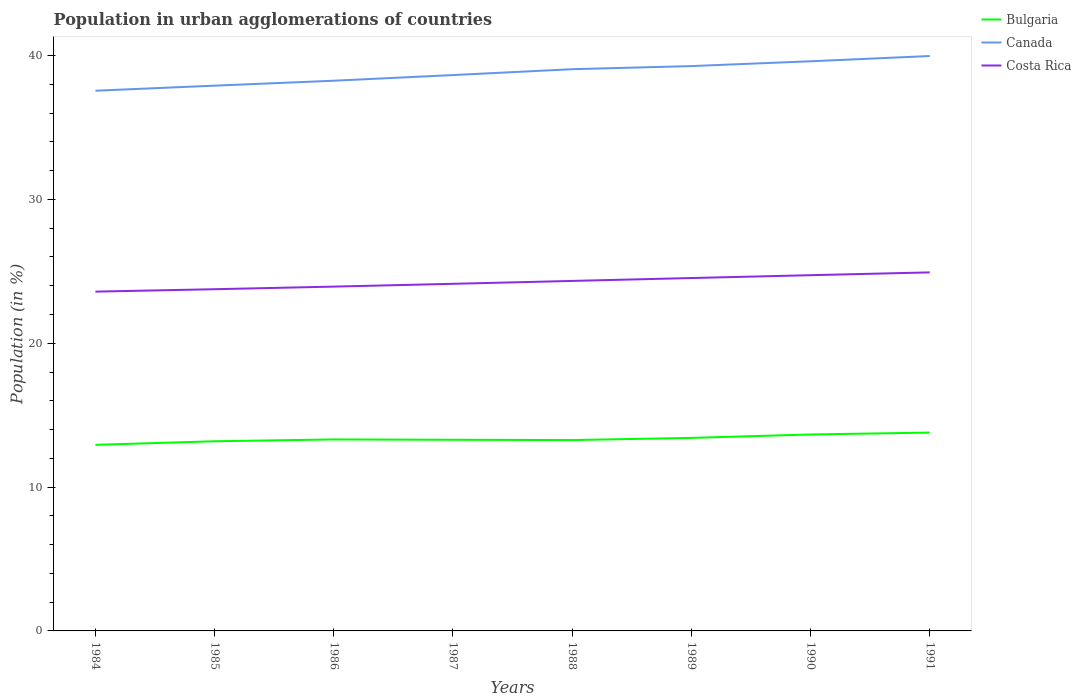Is the number of lines equal to the number of legend labels?
Provide a short and direct response. Yes. Across all years, what is the maximum percentage of population in urban agglomerations in Bulgaria?
Your response must be concise. 12.94. What is the total percentage of population in urban agglomerations in Canada in the graph?
Provide a succinct answer. -1.5. What is the difference between the highest and the second highest percentage of population in urban agglomerations in Bulgaria?
Give a very brief answer. 0.85. Is the percentage of population in urban agglomerations in Bulgaria strictly greater than the percentage of population in urban agglomerations in Costa Rica over the years?
Provide a short and direct response. Yes. What is the difference between two consecutive major ticks on the Y-axis?
Your response must be concise. 10. Does the graph contain any zero values?
Provide a short and direct response. No. Does the graph contain grids?
Your answer should be very brief. No. What is the title of the graph?
Offer a very short reply. Population in urban agglomerations of countries. Does "Comoros" appear as one of the legend labels in the graph?
Your answer should be very brief. No. What is the Population (in %) in Bulgaria in 1984?
Your answer should be compact. 12.94. What is the Population (in %) of Canada in 1984?
Ensure brevity in your answer.  37.56. What is the Population (in %) of Costa Rica in 1984?
Ensure brevity in your answer.  23.59. What is the Population (in %) of Bulgaria in 1985?
Your response must be concise. 13.19. What is the Population (in %) of Canada in 1985?
Provide a succinct answer. 37.91. What is the Population (in %) of Costa Rica in 1985?
Give a very brief answer. 23.76. What is the Population (in %) in Bulgaria in 1986?
Your answer should be very brief. 13.31. What is the Population (in %) in Canada in 1986?
Ensure brevity in your answer.  38.25. What is the Population (in %) in Costa Rica in 1986?
Give a very brief answer. 23.94. What is the Population (in %) of Bulgaria in 1987?
Keep it short and to the point. 13.29. What is the Population (in %) in Canada in 1987?
Keep it short and to the point. 38.64. What is the Population (in %) of Costa Rica in 1987?
Your response must be concise. 24.13. What is the Population (in %) in Bulgaria in 1988?
Give a very brief answer. 13.27. What is the Population (in %) in Canada in 1988?
Ensure brevity in your answer.  39.05. What is the Population (in %) in Costa Rica in 1988?
Give a very brief answer. 24.33. What is the Population (in %) in Bulgaria in 1989?
Keep it short and to the point. 13.42. What is the Population (in %) of Canada in 1989?
Your answer should be compact. 39.27. What is the Population (in %) in Costa Rica in 1989?
Offer a very short reply. 24.53. What is the Population (in %) in Bulgaria in 1990?
Offer a terse response. 13.66. What is the Population (in %) in Canada in 1990?
Keep it short and to the point. 39.6. What is the Population (in %) of Costa Rica in 1990?
Give a very brief answer. 24.73. What is the Population (in %) in Bulgaria in 1991?
Offer a very short reply. 13.79. What is the Population (in %) in Canada in 1991?
Offer a terse response. 39.97. What is the Population (in %) in Costa Rica in 1991?
Make the answer very short. 24.93. Across all years, what is the maximum Population (in %) in Bulgaria?
Ensure brevity in your answer.  13.79. Across all years, what is the maximum Population (in %) in Canada?
Ensure brevity in your answer.  39.97. Across all years, what is the maximum Population (in %) in Costa Rica?
Provide a succinct answer. 24.93. Across all years, what is the minimum Population (in %) in Bulgaria?
Provide a succinct answer. 12.94. Across all years, what is the minimum Population (in %) in Canada?
Your answer should be very brief. 37.56. Across all years, what is the minimum Population (in %) in Costa Rica?
Provide a short and direct response. 23.59. What is the total Population (in %) of Bulgaria in the graph?
Your response must be concise. 106.86. What is the total Population (in %) in Canada in the graph?
Your answer should be very brief. 310.25. What is the total Population (in %) of Costa Rica in the graph?
Give a very brief answer. 193.94. What is the difference between the Population (in %) of Bulgaria in 1984 and that in 1985?
Your answer should be compact. -0.25. What is the difference between the Population (in %) of Canada in 1984 and that in 1985?
Make the answer very short. -0.35. What is the difference between the Population (in %) of Costa Rica in 1984 and that in 1985?
Give a very brief answer. -0.17. What is the difference between the Population (in %) of Bulgaria in 1984 and that in 1986?
Provide a short and direct response. -0.38. What is the difference between the Population (in %) of Canada in 1984 and that in 1986?
Provide a short and direct response. -0.69. What is the difference between the Population (in %) of Costa Rica in 1984 and that in 1986?
Your response must be concise. -0.35. What is the difference between the Population (in %) of Bulgaria in 1984 and that in 1987?
Ensure brevity in your answer.  -0.35. What is the difference between the Population (in %) in Canada in 1984 and that in 1987?
Offer a terse response. -1.09. What is the difference between the Population (in %) in Costa Rica in 1984 and that in 1987?
Provide a short and direct response. -0.54. What is the difference between the Population (in %) in Bulgaria in 1984 and that in 1988?
Provide a short and direct response. -0.33. What is the difference between the Population (in %) in Canada in 1984 and that in 1988?
Keep it short and to the point. -1.5. What is the difference between the Population (in %) in Costa Rica in 1984 and that in 1988?
Your answer should be very brief. -0.74. What is the difference between the Population (in %) of Bulgaria in 1984 and that in 1989?
Provide a succinct answer. -0.48. What is the difference between the Population (in %) in Canada in 1984 and that in 1989?
Keep it short and to the point. -1.71. What is the difference between the Population (in %) of Costa Rica in 1984 and that in 1989?
Your response must be concise. -0.95. What is the difference between the Population (in %) of Bulgaria in 1984 and that in 1990?
Offer a very short reply. -0.72. What is the difference between the Population (in %) in Canada in 1984 and that in 1990?
Your answer should be very brief. -2.05. What is the difference between the Population (in %) in Costa Rica in 1984 and that in 1990?
Your answer should be very brief. -1.14. What is the difference between the Population (in %) in Bulgaria in 1984 and that in 1991?
Your response must be concise. -0.85. What is the difference between the Population (in %) in Canada in 1984 and that in 1991?
Provide a succinct answer. -2.41. What is the difference between the Population (in %) in Costa Rica in 1984 and that in 1991?
Ensure brevity in your answer.  -1.34. What is the difference between the Population (in %) of Bulgaria in 1985 and that in 1986?
Provide a short and direct response. -0.13. What is the difference between the Population (in %) in Canada in 1985 and that in 1986?
Your response must be concise. -0.34. What is the difference between the Population (in %) in Costa Rica in 1985 and that in 1986?
Your answer should be very brief. -0.18. What is the difference between the Population (in %) of Bulgaria in 1985 and that in 1987?
Give a very brief answer. -0.1. What is the difference between the Population (in %) in Canada in 1985 and that in 1987?
Your answer should be compact. -0.74. What is the difference between the Population (in %) in Costa Rica in 1985 and that in 1987?
Your answer should be compact. -0.38. What is the difference between the Population (in %) of Bulgaria in 1985 and that in 1988?
Offer a very short reply. -0.08. What is the difference between the Population (in %) in Canada in 1985 and that in 1988?
Make the answer very short. -1.14. What is the difference between the Population (in %) in Costa Rica in 1985 and that in 1988?
Give a very brief answer. -0.58. What is the difference between the Population (in %) of Bulgaria in 1985 and that in 1989?
Your answer should be very brief. -0.23. What is the difference between the Population (in %) in Canada in 1985 and that in 1989?
Ensure brevity in your answer.  -1.36. What is the difference between the Population (in %) of Costa Rica in 1985 and that in 1989?
Your answer should be very brief. -0.78. What is the difference between the Population (in %) in Bulgaria in 1985 and that in 1990?
Your response must be concise. -0.47. What is the difference between the Population (in %) in Canada in 1985 and that in 1990?
Ensure brevity in your answer.  -1.7. What is the difference between the Population (in %) of Costa Rica in 1985 and that in 1990?
Give a very brief answer. -0.98. What is the difference between the Population (in %) of Bulgaria in 1985 and that in 1991?
Your answer should be compact. -0.6. What is the difference between the Population (in %) of Canada in 1985 and that in 1991?
Your answer should be very brief. -2.06. What is the difference between the Population (in %) in Costa Rica in 1985 and that in 1991?
Ensure brevity in your answer.  -1.17. What is the difference between the Population (in %) in Bulgaria in 1986 and that in 1987?
Provide a short and direct response. 0.02. What is the difference between the Population (in %) in Canada in 1986 and that in 1987?
Provide a succinct answer. -0.39. What is the difference between the Population (in %) in Costa Rica in 1986 and that in 1987?
Make the answer very short. -0.2. What is the difference between the Population (in %) in Bulgaria in 1986 and that in 1988?
Provide a succinct answer. 0.04. What is the difference between the Population (in %) of Canada in 1986 and that in 1988?
Provide a succinct answer. -0.8. What is the difference between the Population (in %) in Costa Rica in 1986 and that in 1988?
Offer a terse response. -0.4. What is the difference between the Population (in %) in Bulgaria in 1986 and that in 1989?
Your response must be concise. -0.11. What is the difference between the Population (in %) in Canada in 1986 and that in 1989?
Make the answer very short. -1.02. What is the difference between the Population (in %) in Costa Rica in 1986 and that in 1989?
Your response must be concise. -0.6. What is the difference between the Population (in %) in Bulgaria in 1986 and that in 1990?
Offer a terse response. -0.35. What is the difference between the Population (in %) in Canada in 1986 and that in 1990?
Your answer should be very brief. -1.35. What is the difference between the Population (in %) of Costa Rica in 1986 and that in 1990?
Provide a succinct answer. -0.79. What is the difference between the Population (in %) of Bulgaria in 1986 and that in 1991?
Keep it short and to the point. -0.48. What is the difference between the Population (in %) in Canada in 1986 and that in 1991?
Make the answer very short. -1.72. What is the difference between the Population (in %) in Costa Rica in 1986 and that in 1991?
Provide a short and direct response. -0.99. What is the difference between the Population (in %) of Canada in 1987 and that in 1988?
Provide a short and direct response. -0.41. What is the difference between the Population (in %) in Costa Rica in 1987 and that in 1988?
Make the answer very short. -0.2. What is the difference between the Population (in %) of Bulgaria in 1987 and that in 1989?
Your response must be concise. -0.13. What is the difference between the Population (in %) of Canada in 1987 and that in 1989?
Offer a very short reply. -0.62. What is the difference between the Population (in %) in Costa Rica in 1987 and that in 1989?
Your response must be concise. -0.4. What is the difference between the Population (in %) of Bulgaria in 1987 and that in 1990?
Your answer should be compact. -0.37. What is the difference between the Population (in %) in Canada in 1987 and that in 1990?
Your response must be concise. -0.96. What is the difference between the Population (in %) in Costa Rica in 1987 and that in 1990?
Your answer should be very brief. -0.6. What is the difference between the Population (in %) in Bulgaria in 1987 and that in 1991?
Your response must be concise. -0.5. What is the difference between the Population (in %) of Canada in 1987 and that in 1991?
Give a very brief answer. -1.32. What is the difference between the Population (in %) of Costa Rica in 1987 and that in 1991?
Make the answer very short. -0.79. What is the difference between the Population (in %) in Bulgaria in 1988 and that in 1989?
Your answer should be compact. -0.15. What is the difference between the Population (in %) of Canada in 1988 and that in 1989?
Offer a very short reply. -0.22. What is the difference between the Population (in %) of Costa Rica in 1988 and that in 1989?
Ensure brevity in your answer.  -0.2. What is the difference between the Population (in %) of Bulgaria in 1988 and that in 1990?
Give a very brief answer. -0.39. What is the difference between the Population (in %) in Canada in 1988 and that in 1990?
Ensure brevity in your answer.  -0.55. What is the difference between the Population (in %) of Costa Rica in 1988 and that in 1990?
Ensure brevity in your answer.  -0.4. What is the difference between the Population (in %) in Bulgaria in 1988 and that in 1991?
Offer a terse response. -0.52. What is the difference between the Population (in %) in Canada in 1988 and that in 1991?
Provide a short and direct response. -0.92. What is the difference between the Population (in %) of Costa Rica in 1988 and that in 1991?
Keep it short and to the point. -0.59. What is the difference between the Population (in %) of Bulgaria in 1989 and that in 1990?
Make the answer very short. -0.24. What is the difference between the Population (in %) of Canada in 1989 and that in 1990?
Your answer should be very brief. -0.33. What is the difference between the Population (in %) of Costa Rica in 1989 and that in 1990?
Offer a terse response. -0.2. What is the difference between the Population (in %) of Bulgaria in 1989 and that in 1991?
Keep it short and to the point. -0.37. What is the difference between the Population (in %) in Canada in 1989 and that in 1991?
Offer a terse response. -0.7. What is the difference between the Population (in %) of Costa Rica in 1989 and that in 1991?
Keep it short and to the point. -0.39. What is the difference between the Population (in %) in Bulgaria in 1990 and that in 1991?
Your response must be concise. -0.13. What is the difference between the Population (in %) in Canada in 1990 and that in 1991?
Provide a short and direct response. -0.37. What is the difference between the Population (in %) of Costa Rica in 1990 and that in 1991?
Make the answer very short. -0.19. What is the difference between the Population (in %) in Bulgaria in 1984 and the Population (in %) in Canada in 1985?
Your answer should be very brief. -24.97. What is the difference between the Population (in %) of Bulgaria in 1984 and the Population (in %) of Costa Rica in 1985?
Offer a terse response. -10.82. What is the difference between the Population (in %) in Canada in 1984 and the Population (in %) in Costa Rica in 1985?
Offer a terse response. 13.8. What is the difference between the Population (in %) of Bulgaria in 1984 and the Population (in %) of Canada in 1986?
Your response must be concise. -25.31. What is the difference between the Population (in %) in Bulgaria in 1984 and the Population (in %) in Costa Rica in 1986?
Give a very brief answer. -11. What is the difference between the Population (in %) of Canada in 1984 and the Population (in %) of Costa Rica in 1986?
Make the answer very short. 13.62. What is the difference between the Population (in %) in Bulgaria in 1984 and the Population (in %) in Canada in 1987?
Offer a very short reply. -25.71. What is the difference between the Population (in %) in Bulgaria in 1984 and the Population (in %) in Costa Rica in 1987?
Make the answer very short. -11.19. What is the difference between the Population (in %) in Canada in 1984 and the Population (in %) in Costa Rica in 1987?
Your answer should be very brief. 13.42. What is the difference between the Population (in %) in Bulgaria in 1984 and the Population (in %) in Canada in 1988?
Ensure brevity in your answer.  -26.11. What is the difference between the Population (in %) in Bulgaria in 1984 and the Population (in %) in Costa Rica in 1988?
Keep it short and to the point. -11.4. What is the difference between the Population (in %) of Canada in 1984 and the Population (in %) of Costa Rica in 1988?
Keep it short and to the point. 13.22. What is the difference between the Population (in %) in Bulgaria in 1984 and the Population (in %) in Canada in 1989?
Your response must be concise. -26.33. What is the difference between the Population (in %) in Bulgaria in 1984 and the Population (in %) in Costa Rica in 1989?
Keep it short and to the point. -11.6. What is the difference between the Population (in %) in Canada in 1984 and the Population (in %) in Costa Rica in 1989?
Provide a succinct answer. 13.02. What is the difference between the Population (in %) in Bulgaria in 1984 and the Population (in %) in Canada in 1990?
Offer a very short reply. -26.67. What is the difference between the Population (in %) in Bulgaria in 1984 and the Population (in %) in Costa Rica in 1990?
Provide a short and direct response. -11.79. What is the difference between the Population (in %) of Canada in 1984 and the Population (in %) of Costa Rica in 1990?
Keep it short and to the point. 12.83. What is the difference between the Population (in %) in Bulgaria in 1984 and the Population (in %) in Canada in 1991?
Provide a short and direct response. -27.03. What is the difference between the Population (in %) of Bulgaria in 1984 and the Population (in %) of Costa Rica in 1991?
Provide a short and direct response. -11.99. What is the difference between the Population (in %) of Canada in 1984 and the Population (in %) of Costa Rica in 1991?
Ensure brevity in your answer.  12.63. What is the difference between the Population (in %) of Bulgaria in 1985 and the Population (in %) of Canada in 1986?
Your response must be concise. -25.07. What is the difference between the Population (in %) of Bulgaria in 1985 and the Population (in %) of Costa Rica in 1986?
Give a very brief answer. -10.75. What is the difference between the Population (in %) in Canada in 1985 and the Population (in %) in Costa Rica in 1986?
Give a very brief answer. 13.97. What is the difference between the Population (in %) in Bulgaria in 1985 and the Population (in %) in Canada in 1987?
Keep it short and to the point. -25.46. What is the difference between the Population (in %) of Bulgaria in 1985 and the Population (in %) of Costa Rica in 1987?
Provide a short and direct response. -10.95. What is the difference between the Population (in %) of Canada in 1985 and the Population (in %) of Costa Rica in 1987?
Your answer should be very brief. 13.78. What is the difference between the Population (in %) of Bulgaria in 1985 and the Population (in %) of Canada in 1988?
Give a very brief answer. -25.87. What is the difference between the Population (in %) in Bulgaria in 1985 and the Population (in %) in Costa Rica in 1988?
Offer a very short reply. -11.15. What is the difference between the Population (in %) of Canada in 1985 and the Population (in %) of Costa Rica in 1988?
Your response must be concise. 13.57. What is the difference between the Population (in %) in Bulgaria in 1985 and the Population (in %) in Canada in 1989?
Give a very brief answer. -26.08. What is the difference between the Population (in %) in Bulgaria in 1985 and the Population (in %) in Costa Rica in 1989?
Make the answer very short. -11.35. What is the difference between the Population (in %) in Canada in 1985 and the Population (in %) in Costa Rica in 1989?
Offer a terse response. 13.37. What is the difference between the Population (in %) in Bulgaria in 1985 and the Population (in %) in Canada in 1990?
Ensure brevity in your answer.  -26.42. What is the difference between the Population (in %) in Bulgaria in 1985 and the Population (in %) in Costa Rica in 1990?
Provide a short and direct response. -11.55. What is the difference between the Population (in %) of Canada in 1985 and the Population (in %) of Costa Rica in 1990?
Provide a short and direct response. 13.18. What is the difference between the Population (in %) of Bulgaria in 1985 and the Population (in %) of Canada in 1991?
Offer a terse response. -26.78. What is the difference between the Population (in %) of Bulgaria in 1985 and the Population (in %) of Costa Rica in 1991?
Your answer should be compact. -11.74. What is the difference between the Population (in %) in Canada in 1985 and the Population (in %) in Costa Rica in 1991?
Offer a very short reply. 12.98. What is the difference between the Population (in %) in Bulgaria in 1986 and the Population (in %) in Canada in 1987?
Ensure brevity in your answer.  -25.33. What is the difference between the Population (in %) in Bulgaria in 1986 and the Population (in %) in Costa Rica in 1987?
Your answer should be very brief. -10.82. What is the difference between the Population (in %) in Canada in 1986 and the Population (in %) in Costa Rica in 1987?
Provide a short and direct response. 14.12. What is the difference between the Population (in %) in Bulgaria in 1986 and the Population (in %) in Canada in 1988?
Provide a short and direct response. -25.74. What is the difference between the Population (in %) of Bulgaria in 1986 and the Population (in %) of Costa Rica in 1988?
Provide a succinct answer. -11.02. What is the difference between the Population (in %) of Canada in 1986 and the Population (in %) of Costa Rica in 1988?
Your response must be concise. 13.92. What is the difference between the Population (in %) in Bulgaria in 1986 and the Population (in %) in Canada in 1989?
Your answer should be very brief. -25.96. What is the difference between the Population (in %) of Bulgaria in 1986 and the Population (in %) of Costa Rica in 1989?
Make the answer very short. -11.22. What is the difference between the Population (in %) in Canada in 1986 and the Population (in %) in Costa Rica in 1989?
Offer a very short reply. 13.72. What is the difference between the Population (in %) of Bulgaria in 1986 and the Population (in %) of Canada in 1990?
Your answer should be very brief. -26.29. What is the difference between the Population (in %) in Bulgaria in 1986 and the Population (in %) in Costa Rica in 1990?
Make the answer very short. -11.42. What is the difference between the Population (in %) in Canada in 1986 and the Population (in %) in Costa Rica in 1990?
Offer a terse response. 13.52. What is the difference between the Population (in %) in Bulgaria in 1986 and the Population (in %) in Canada in 1991?
Provide a short and direct response. -26.66. What is the difference between the Population (in %) of Bulgaria in 1986 and the Population (in %) of Costa Rica in 1991?
Give a very brief answer. -11.61. What is the difference between the Population (in %) in Canada in 1986 and the Population (in %) in Costa Rica in 1991?
Make the answer very short. 13.33. What is the difference between the Population (in %) in Bulgaria in 1987 and the Population (in %) in Canada in 1988?
Keep it short and to the point. -25.76. What is the difference between the Population (in %) of Bulgaria in 1987 and the Population (in %) of Costa Rica in 1988?
Give a very brief answer. -11.04. What is the difference between the Population (in %) in Canada in 1987 and the Population (in %) in Costa Rica in 1988?
Offer a terse response. 14.31. What is the difference between the Population (in %) in Bulgaria in 1987 and the Population (in %) in Canada in 1989?
Your answer should be very brief. -25.98. What is the difference between the Population (in %) in Bulgaria in 1987 and the Population (in %) in Costa Rica in 1989?
Offer a very short reply. -11.25. What is the difference between the Population (in %) of Canada in 1987 and the Population (in %) of Costa Rica in 1989?
Keep it short and to the point. 14.11. What is the difference between the Population (in %) of Bulgaria in 1987 and the Population (in %) of Canada in 1990?
Your answer should be very brief. -26.31. What is the difference between the Population (in %) in Bulgaria in 1987 and the Population (in %) in Costa Rica in 1990?
Ensure brevity in your answer.  -11.44. What is the difference between the Population (in %) in Canada in 1987 and the Population (in %) in Costa Rica in 1990?
Offer a terse response. 13.91. What is the difference between the Population (in %) of Bulgaria in 1987 and the Population (in %) of Canada in 1991?
Your answer should be very brief. -26.68. What is the difference between the Population (in %) in Bulgaria in 1987 and the Population (in %) in Costa Rica in 1991?
Your answer should be very brief. -11.64. What is the difference between the Population (in %) in Canada in 1987 and the Population (in %) in Costa Rica in 1991?
Offer a terse response. 13.72. What is the difference between the Population (in %) of Bulgaria in 1988 and the Population (in %) of Canada in 1989?
Offer a very short reply. -26. What is the difference between the Population (in %) of Bulgaria in 1988 and the Population (in %) of Costa Rica in 1989?
Provide a short and direct response. -11.27. What is the difference between the Population (in %) in Canada in 1988 and the Population (in %) in Costa Rica in 1989?
Your answer should be very brief. 14.52. What is the difference between the Population (in %) in Bulgaria in 1988 and the Population (in %) in Canada in 1990?
Your answer should be very brief. -26.33. What is the difference between the Population (in %) in Bulgaria in 1988 and the Population (in %) in Costa Rica in 1990?
Make the answer very short. -11.46. What is the difference between the Population (in %) of Canada in 1988 and the Population (in %) of Costa Rica in 1990?
Your answer should be compact. 14.32. What is the difference between the Population (in %) in Bulgaria in 1988 and the Population (in %) in Canada in 1991?
Make the answer very short. -26.7. What is the difference between the Population (in %) of Bulgaria in 1988 and the Population (in %) of Costa Rica in 1991?
Offer a very short reply. -11.66. What is the difference between the Population (in %) in Canada in 1988 and the Population (in %) in Costa Rica in 1991?
Ensure brevity in your answer.  14.13. What is the difference between the Population (in %) of Bulgaria in 1989 and the Population (in %) of Canada in 1990?
Make the answer very short. -26.18. What is the difference between the Population (in %) of Bulgaria in 1989 and the Population (in %) of Costa Rica in 1990?
Your answer should be very brief. -11.31. What is the difference between the Population (in %) in Canada in 1989 and the Population (in %) in Costa Rica in 1990?
Provide a short and direct response. 14.54. What is the difference between the Population (in %) in Bulgaria in 1989 and the Population (in %) in Canada in 1991?
Give a very brief answer. -26.55. What is the difference between the Population (in %) of Bulgaria in 1989 and the Population (in %) of Costa Rica in 1991?
Ensure brevity in your answer.  -11.51. What is the difference between the Population (in %) of Canada in 1989 and the Population (in %) of Costa Rica in 1991?
Ensure brevity in your answer.  14.34. What is the difference between the Population (in %) in Bulgaria in 1990 and the Population (in %) in Canada in 1991?
Provide a succinct answer. -26.31. What is the difference between the Population (in %) of Bulgaria in 1990 and the Population (in %) of Costa Rica in 1991?
Keep it short and to the point. -11.27. What is the difference between the Population (in %) in Canada in 1990 and the Population (in %) in Costa Rica in 1991?
Your answer should be very brief. 14.68. What is the average Population (in %) of Bulgaria per year?
Ensure brevity in your answer.  13.36. What is the average Population (in %) in Canada per year?
Provide a succinct answer. 38.78. What is the average Population (in %) in Costa Rica per year?
Provide a short and direct response. 24.24. In the year 1984, what is the difference between the Population (in %) in Bulgaria and Population (in %) in Canada?
Ensure brevity in your answer.  -24.62. In the year 1984, what is the difference between the Population (in %) of Bulgaria and Population (in %) of Costa Rica?
Ensure brevity in your answer.  -10.65. In the year 1984, what is the difference between the Population (in %) in Canada and Population (in %) in Costa Rica?
Provide a short and direct response. 13.97. In the year 1985, what is the difference between the Population (in %) in Bulgaria and Population (in %) in Canada?
Make the answer very short. -24.72. In the year 1985, what is the difference between the Population (in %) of Bulgaria and Population (in %) of Costa Rica?
Ensure brevity in your answer.  -10.57. In the year 1985, what is the difference between the Population (in %) in Canada and Population (in %) in Costa Rica?
Offer a terse response. 14.15. In the year 1986, what is the difference between the Population (in %) of Bulgaria and Population (in %) of Canada?
Offer a terse response. -24.94. In the year 1986, what is the difference between the Population (in %) in Bulgaria and Population (in %) in Costa Rica?
Your answer should be very brief. -10.62. In the year 1986, what is the difference between the Population (in %) of Canada and Population (in %) of Costa Rica?
Offer a terse response. 14.31. In the year 1987, what is the difference between the Population (in %) of Bulgaria and Population (in %) of Canada?
Offer a very short reply. -25.36. In the year 1987, what is the difference between the Population (in %) of Bulgaria and Population (in %) of Costa Rica?
Provide a short and direct response. -10.84. In the year 1987, what is the difference between the Population (in %) of Canada and Population (in %) of Costa Rica?
Make the answer very short. 14.51. In the year 1988, what is the difference between the Population (in %) of Bulgaria and Population (in %) of Canada?
Make the answer very short. -25.78. In the year 1988, what is the difference between the Population (in %) in Bulgaria and Population (in %) in Costa Rica?
Give a very brief answer. -11.06. In the year 1988, what is the difference between the Population (in %) of Canada and Population (in %) of Costa Rica?
Keep it short and to the point. 14.72. In the year 1989, what is the difference between the Population (in %) in Bulgaria and Population (in %) in Canada?
Provide a short and direct response. -25.85. In the year 1989, what is the difference between the Population (in %) of Bulgaria and Population (in %) of Costa Rica?
Your answer should be very brief. -11.12. In the year 1989, what is the difference between the Population (in %) in Canada and Population (in %) in Costa Rica?
Keep it short and to the point. 14.73. In the year 1990, what is the difference between the Population (in %) of Bulgaria and Population (in %) of Canada?
Your answer should be very brief. -25.94. In the year 1990, what is the difference between the Population (in %) in Bulgaria and Population (in %) in Costa Rica?
Your response must be concise. -11.07. In the year 1990, what is the difference between the Population (in %) in Canada and Population (in %) in Costa Rica?
Provide a short and direct response. 14.87. In the year 1991, what is the difference between the Population (in %) of Bulgaria and Population (in %) of Canada?
Give a very brief answer. -26.18. In the year 1991, what is the difference between the Population (in %) in Bulgaria and Population (in %) in Costa Rica?
Ensure brevity in your answer.  -11.14. In the year 1991, what is the difference between the Population (in %) in Canada and Population (in %) in Costa Rica?
Provide a short and direct response. 15.04. What is the ratio of the Population (in %) in Bulgaria in 1984 to that in 1985?
Provide a short and direct response. 0.98. What is the ratio of the Population (in %) of Costa Rica in 1984 to that in 1985?
Make the answer very short. 0.99. What is the ratio of the Population (in %) of Bulgaria in 1984 to that in 1986?
Offer a very short reply. 0.97. What is the ratio of the Population (in %) of Canada in 1984 to that in 1986?
Ensure brevity in your answer.  0.98. What is the ratio of the Population (in %) of Costa Rica in 1984 to that in 1986?
Provide a short and direct response. 0.99. What is the ratio of the Population (in %) of Bulgaria in 1984 to that in 1987?
Your answer should be very brief. 0.97. What is the ratio of the Population (in %) in Canada in 1984 to that in 1987?
Give a very brief answer. 0.97. What is the ratio of the Population (in %) in Costa Rica in 1984 to that in 1987?
Make the answer very short. 0.98. What is the ratio of the Population (in %) in Bulgaria in 1984 to that in 1988?
Provide a short and direct response. 0.98. What is the ratio of the Population (in %) in Canada in 1984 to that in 1988?
Your answer should be very brief. 0.96. What is the ratio of the Population (in %) of Costa Rica in 1984 to that in 1988?
Keep it short and to the point. 0.97. What is the ratio of the Population (in %) of Bulgaria in 1984 to that in 1989?
Your response must be concise. 0.96. What is the ratio of the Population (in %) of Canada in 1984 to that in 1989?
Provide a succinct answer. 0.96. What is the ratio of the Population (in %) in Costa Rica in 1984 to that in 1989?
Your answer should be compact. 0.96. What is the ratio of the Population (in %) in Bulgaria in 1984 to that in 1990?
Give a very brief answer. 0.95. What is the ratio of the Population (in %) in Canada in 1984 to that in 1990?
Offer a terse response. 0.95. What is the ratio of the Population (in %) in Costa Rica in 1984 to that in 1990?
Give a very brief answer. 0.95. What is the ratio of the Population (in %) in Bulgaria in 1984 to that in 1991?
Provide a succinct answer. 0.94. What is the ratio of the Population (in %) of Canada in 1984 to that in 1991?
Give a very brief answer. 0.94. What is the ratio of the Population (in %) of Costa Rica in 1984 to that in 1991?
Make the answer very short. 0.95. What is the ratio of the Population (in %) of Costa Rica in 1985 to that in 1986?
Keep it short and to the point. 0.99. What is the ratio of the Population (in %) of Bulgaria in 1985 to that in 1987?
Provide a short and direct response. 0.99. What is the ratio of the Population (in %) in Canada in 1985 to that in 1987?
Offer a terse response. 0.98. What is the ratio of the Population (in %) of Costa Rica in 1985 to that in 1987?
Your answer should be compact. 0.98. What is the ratio of the Population (in %) in Canada in 1985 to that in 1988?
Provide a succinct answer. 0.97. What is the ratio of the Population (in %) of Costa Rica in 1985 to that in 1988?
Offer a terse response. 0.98. What is the ratio of the Population (in %) of Bulgaria in 1985 to that in 1989?
Ensure brevity in your answer.  0.98. What is the ratio of the Population (in %) of Canada in 1985 to that in 1989?
Offer a very short reply. 0.97. What is the ratio of the Population (in %) in Costa Rica in 1985 to that in 1989?
Offer a very short reply. 0.97. What is the ratio of the Population (in %) in Bulgaria in 1985 to that in 1990?
Your answer should be very brief. 0.97. What is the ratio of the Population (in %) of Canada in 1985 to that in 1990?
Offer a very short reply. 0.96. What is the ratio of the Population (in %) in Costa Rica in 1985 to that in 1990?
Give a very brief answer. 0.96. What is the ratio of the Population (in %) in Bulgaria in 1985 to that in 1991?
Ensure brevity in your answer.  0.96. What is the ratio of the Population (in %) of Canada in 1985 to that in 1991?
Offer a terse response. 0.95. What is the ratio of the Population (in %) of Costa Rica in 1985 to that in 1991?
Provide a succinct answer. 0.95. What is the ratio of the Population (in %) of Bulgaria in 1986 to that in 1987?
Provide a succinct answer. 1. What is the ratio of the Population (in %) in Canada in 1986 to that in 1987?
Your answer should be compact. 0.99. What is the ratio of the Population (in %) of Costa Rica in 1986 to that in 1987?
Provide a succinct answer. 0.99. What is the ratio of the Population (in %) of Canada in 1986 to that in 1988?
Your answer should be very brief. 0.98. What is the ratio of the Population (in %) in Costa Rica in 1986 to that in 1988?
Provide a succinct answer. 0.98. What is the ratio of the Population (in %) in Canada in 1986 to that in 1989?
Ensure brevity in your answer.  0.97. What is the ratio of the Population (in %) in Costa Rica in 1986 to that in 1989?
Your answer should be compact. 0.98. What is the ratio of the Population (in %) of Bulgaria in 1986 to that in 1990?
Provide a succinct answer. 0.97. What is the ratio of the Population (in %) in Canada in 1986 to that in 1990?
Provide a succinct answer. 0.97. What is the ratio of the Population (in %) in Costa Rica in 1986 to that in 1990?
Offer a terse response. 0.97. What is the ratio of the Population (in %) in Bulgaria in 1986 to that in 1991?
Make the answer very short. 0.97. What is the ratio of the Population (in %) in Costa Rica in 1986 to that in 1991?
Ensure brevity in your answer.  0.96. What is the ratio of the Population (in %) of Bulgaria in 1987 to that in 1988?
Your answer should be compact. 1. What is the ratio of the Population (in %) in Canada in 1987 to that in 1988?
Keep it short and to the point. 0.99. What is the ratio of the Population (in %) in Bulgaria in 1987 to that in 1989?
Ensure brevity in your answer.  0.99. What is the ratio of the Population (in %) of Canada in 1987 to that in 1989?
Offer a very short reply. 0.98. What is the ratio of the Population (in %) in Costa Rica in 1987 to that in 1989?
Provide a succinct answer. 0.98. What is the ratio of the Population (in %) in Bulgaria in 1987 to that in 1990?
Your response must be concise. 0.97. What is the ratio of the Population (in %) in Canada in 1987 to that in 1990?
Your answer should be very brief. 0.98. What is the ratio of the Population (in %) in Costa Rica in 1987 to that in 1990?
Your response must be concise. 0.98. What is the ratio of the Population (in %) of Bulgaria in 1987 to that in 1991?
Give a very brief answer. 0.96. What is the ratio of the Population (in %) in Canada in 1987 to that in 1991?
Your response must be concise. 0.97. What is the ratio of the Population (in %) of Costa Rica in 1987 to that in 1991?
Offer a very short reply. 0.97. What is the ratio of the Population (in %) of Bulgaria in 1988 to that in 1989?
Your response must be concise. 0.99. What is the ratio of the Population (in %) of Canada in 1988 to that in 1989?
Keep it short and to the point. 0.99. What is the ratio of the Population (in %) in Bulgaria in 1988 to that in 1990?
Your response must be concise. 0.97. What is the ratio of the Population (in %) of Canada in 1988 to that in 1990?
Provide a short and direct response. 0.99. What is the ratio of the Population (in %) in Costa Rica in 1988 to that in 1990?
Provide a short and direct response. 0.98. What is the ratio of the Population (in %) in Bulgaria in 1988 to that in 1991?
Ensure brevity in your answer.  0.96. What is the ratio of the Population (in %) in Canada in 1988 to that in 1991?
Offer a terse response. 0.98. What is the ratio of the Population (in %) of Costa Rica in 1988 to that in 1991?
Ensure brevity in your answer.  0.98. What is the ratio of the Population (in %) of Bulgaria in 1989 to that in 1990?
Provide a short and direct response. 0.98. What is the ratio of the Population (in %) of Bulgaria in 1989 to that in 1991?
Give a very brief answer. 0.97. What is the ratio of the Population (in %) of Canada in 1989 to that in 1991?
Offer a very short reply. 0.98. What is the ratio of the Population (in %) of Costa Rica in 1989 to that in 1991?
Your answer should be compact. 0.98. What is the ratio of the Population (in %) of Bulgaria in 1990 to that in 1991?
Your answer should be very brief. 0.99. What is the ratio of the Population (in %) of Canada in 1990 to that in 1991?
Offer a very short reply. 0.99. What is the difference between the highest and the second highest Population (in %) in Bulgaria?
Provide a succinct answer. 0.13. What is the difference between the highest and the second highest Population (in %) in Canada?
Keep it short and to the point. 0.37. What is the difference between the highest and the second highest Population (in %) in Costa Rica?
Provide a succinct answer. 0.19. What is the difference between the highest and the lowest Population (in %) in Bulgaria?
Your answer should be compact. 0.85. What is the difference between the highest and the lowest Population (in %) of Canada?
Offer a very short reply. 2.41. What is the difference between the highest and the lowest Population (in %) of Costa Rica?
Provide a succinct answer. 1.34. 